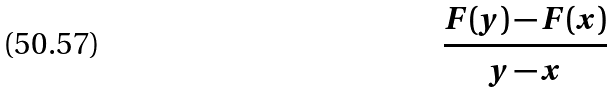Convert formula to latex. <formula><loc_0><loc_0><loc_500><loc_500>\frac { F ( y ) - F ( x ) } { y - x }</formula> 